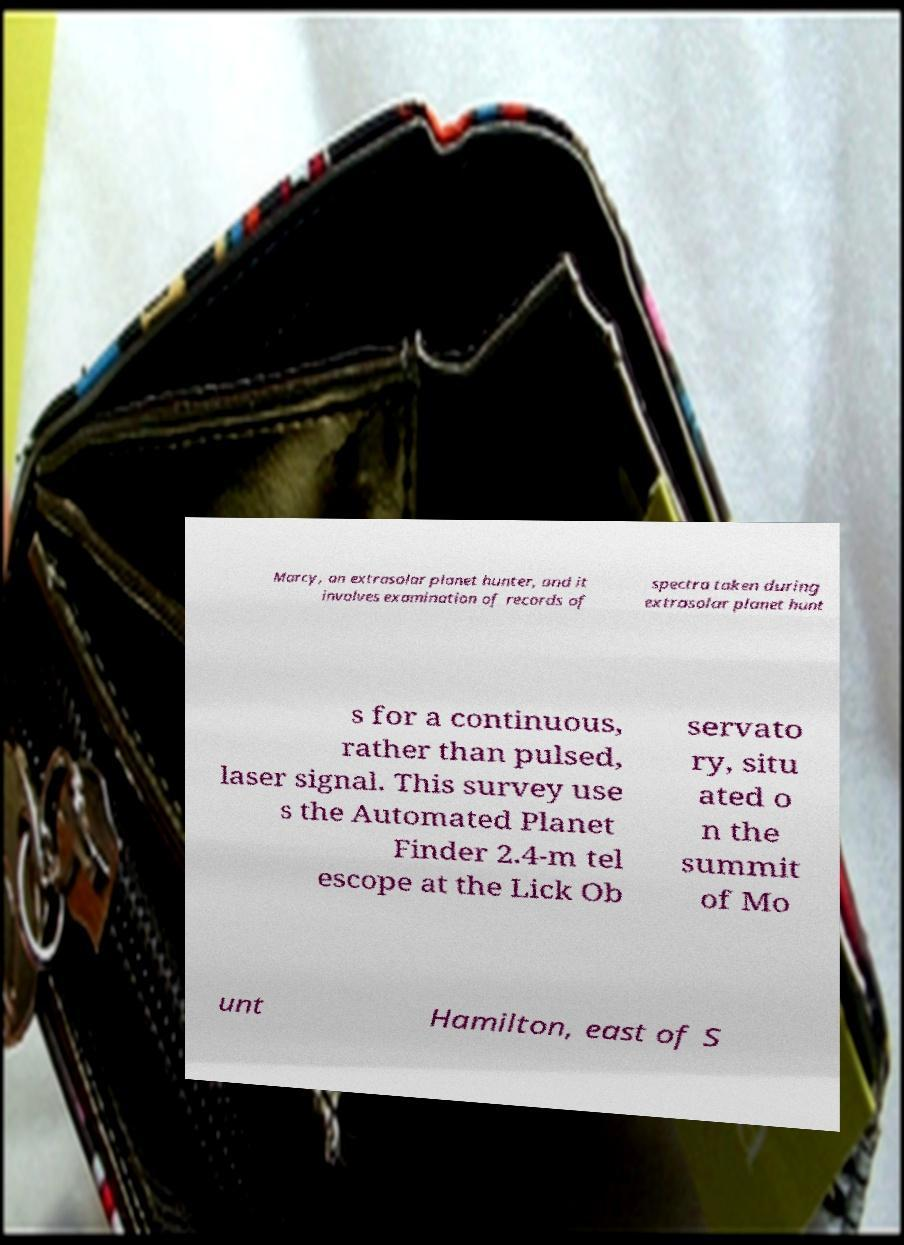For documentation purposes, I need the text within this image transcribed. Could you provide that? Marcy, an extrasolar planet hunter, and it involves examination of records of spectra taken during extrasolar planet hunt s for a continuous, rather than pulsed, laser signal. This survey use s the Automated Planet Finder 2.4-m tel escope at the Lick Ob servato ry, situ ated o n the summit of Mo unt Hamilton, east of S 